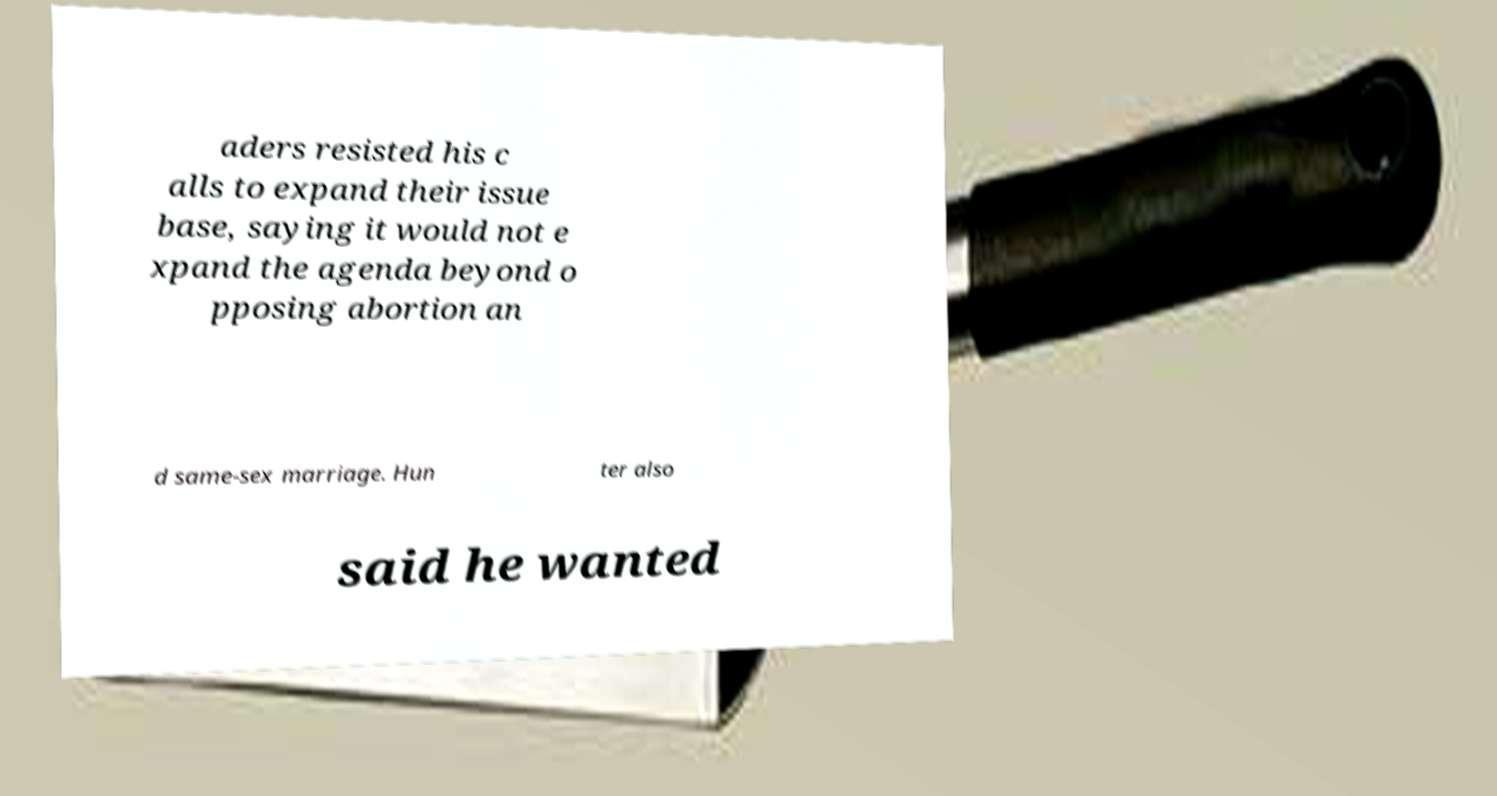Please identify and transcribe the text found in this image. aders resisted his c alls to expand their issue base, saying it would not e xpand the agenda beyond o pposing abortion an d same-sex marriage. Hun ter also said he wanted 